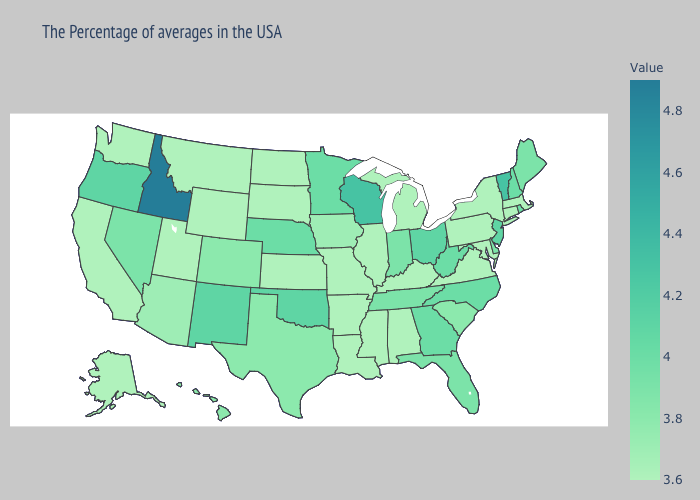Which states have the highest value in the USA?
Keep it brief. Idaho. Does Georgia have a higher value than Kentucky?
Quick response, please. Yes. Which states hav the highest value in the South?
Answer briefly. Oklahoma. Does Vermont have a higher value than Alabama?
Answer briefly. Yes. Among the states that border Iowa , which have the highest value?
Write a very short answer. Wisconsin. 